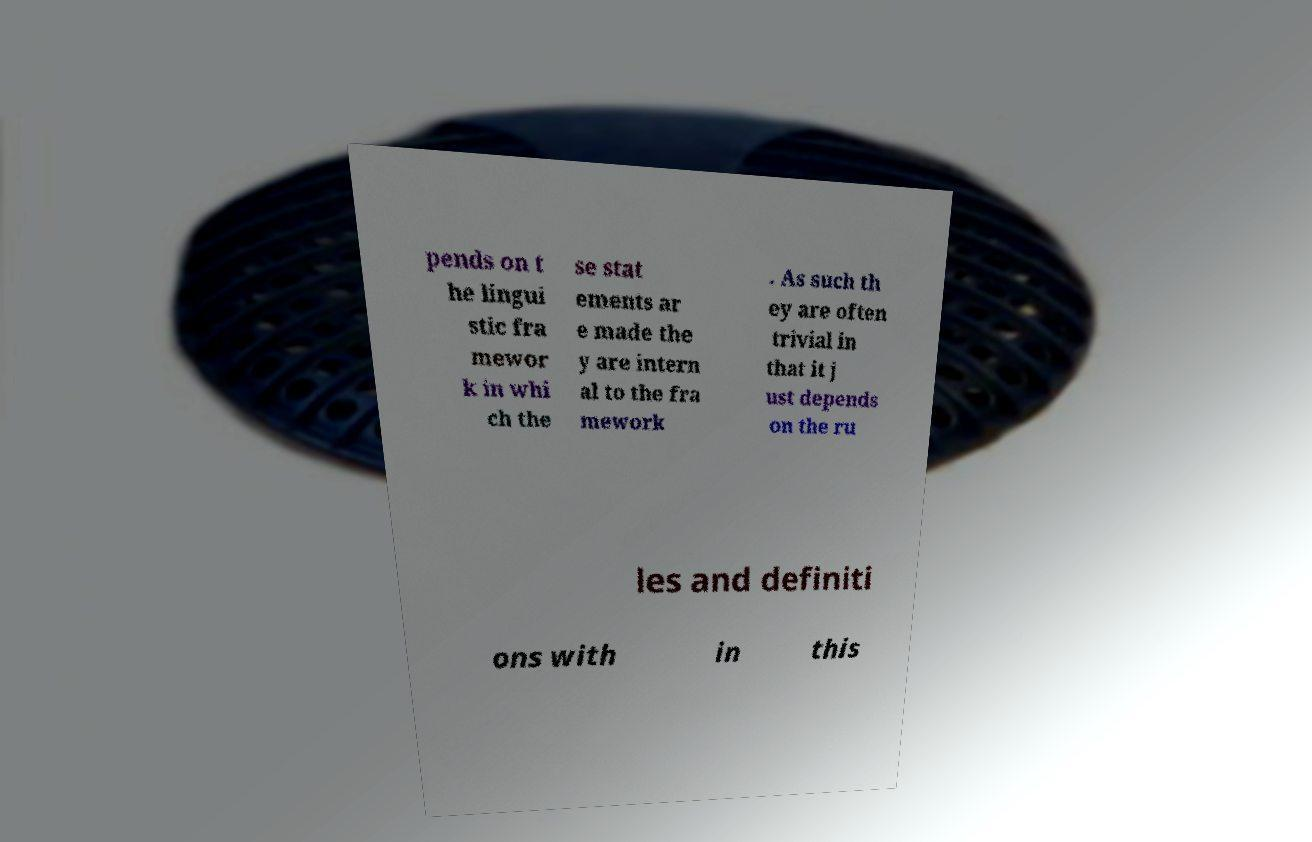Can you accurately transcribe the text from the provided image for me? pends on t he lingui stic fra mewor k in whi ch the se stat ements ar e made the y are intern al to the fra mework . As such th ey are often trivial in that it j ust depends on the ru les and definiti ons with in this 